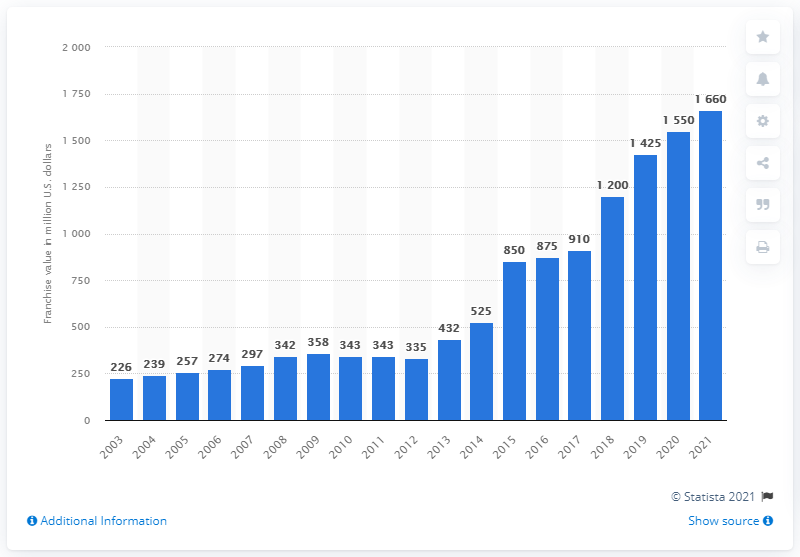Specify some key components in this picture. According to estimates, the value of the Utah Jazz in 2021 was approximately 1660. 